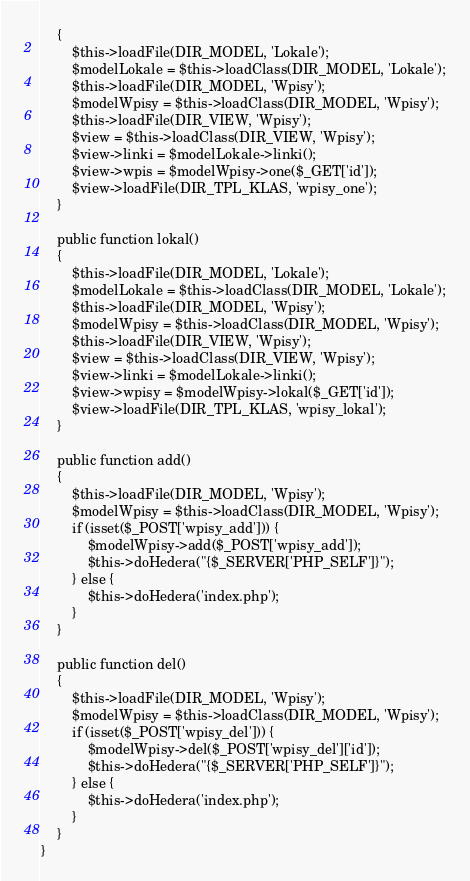Convert code to text. <code><loc_0><loc_0><loc_500><loc_500><_PHP_>    {
        $this->loadFile(DIR_MODEL, 'Lokale');
        $modelLokale = $this->loadClass(DIR_MODEL, 'Lokale');
        $this->loadFile(DIR_MODEL, 'Wpisy');
        $modelWpisy = $this->loadClass(DIR_MODEL, 'Wpisy');
        $this->loadFile(DIR_VIEW, 'Wpisy');
        $view = $this->loadClass(DIR_VIEW, 'Wpisy');
        $view->linki = $modelLokale->linki();
        $view->wpis = $modelWpisy->one($_GET['id']);
        $view->loadFile(DIR_TPL_KLAS, 'wpisy_one');
    }
    
    public function lokal()
    {
        $this->loadFile(DIR_MODEL, 'Lokale');
        $modelLokale = $this->loadClass(DIR_MODEL, 'Lokale');
        $this->loadFile(DIR_MODEL, 'Wpisy');
        $modelWpisy = $this->loadClass(DIR_MODEL, 'Wpisy');
        $this->loadFile(DIR_VIEW, 'Wpisy');
        $view = $this->loadClass(DIR_VIEW, 'Wpisy');
        $view->linki = $modelLokale->linki();
        $view->wpisy = $modelWpisy->lokal($_GET['id']);
        $view->loadFile(DIR_TPL_KLAS, 'wpisy_lokal');
    }
    
    public function add()
    {
        $this->loadFile(DIR_MODEL, 'Wpisy');
        $modelWpisy = $this->loadClass(DIR_MODEL, 'Wpisy');
        if (isset($_POST['wpisy_add'])) {
            $modelWpisy->add($_POST['wpisy_add']);
            $this->doHedera("{$_SERVER['PHP_SELF']}");
        } else {
            $this->doHedera('index.php');
        }
    }
    
    public function del()
    {
        $this->loadFile(DIR_MODEL, 'Wpisy');
        $modelWpisy = $this->loadClass(DIR_MODEL, 'Wpisy');
        if (isset($_POST['wpisy_del'])) {
            $modelWpisy->del($_POST['wpisy_del']['id']);
            $this->doHedera("{$_SERVER['PHP_SELF']}");
        } else {
            $this->doHedera('index.php');
        }
    }
}

</code> 